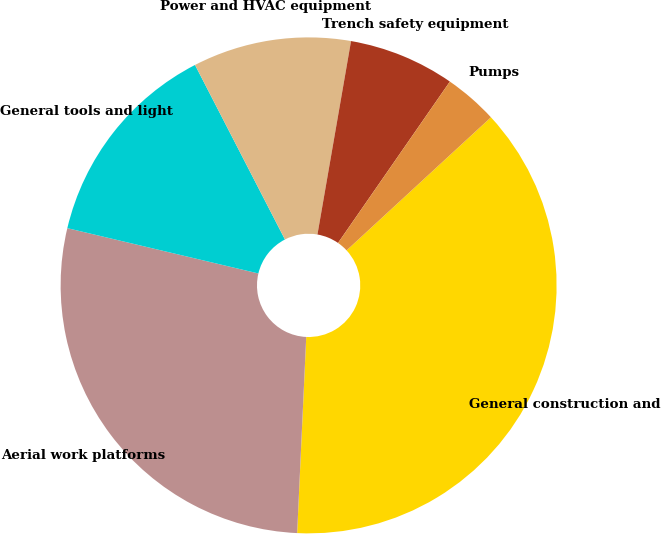Convert chart to OTSL. <chart><loc_0><loc_0><loc_500><loc_500><pie_chart><fcel>General construction and<fcel>Aerial work platforms<fcel>General tools and light<fcel>Power and HVAC equipment<fcel>Trench safety equipment<fcel>Pumps<nl><fcel>37.59%<fcel>27.97%<fcel>13.72%<fcel>10.31%<fcel>6.91%<fcel>3.5%<nl></chart> 